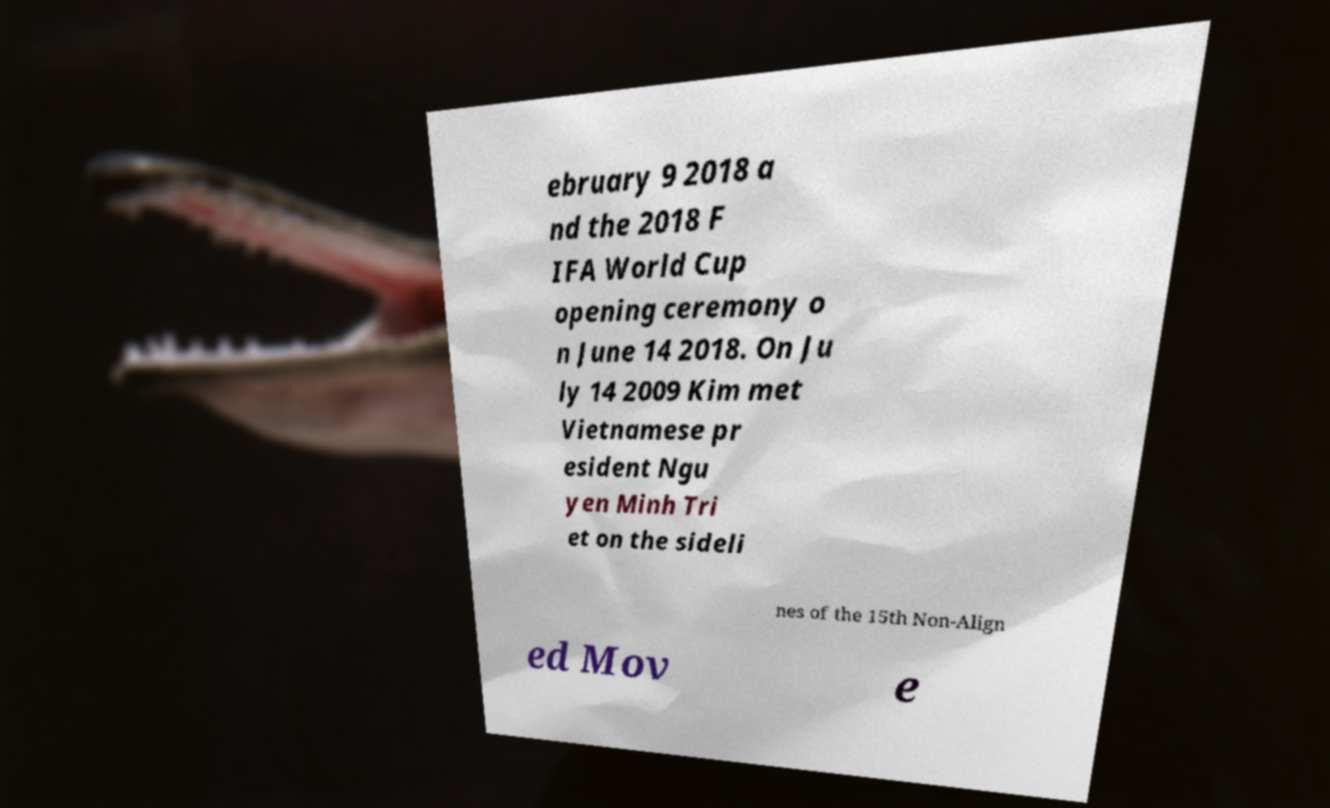Could you assist in decoding the text presented in this image and type it out clearly? ebruary 9 2018 a nd the 2018 F IFA World Cup opening ceremony o n June 14 2018. On Ju ly 14 2009 Kim met Vietnamese pr esident Ngu yen Minh Tri et on the sideli nes of the 15th Non-Align ed Mov e 